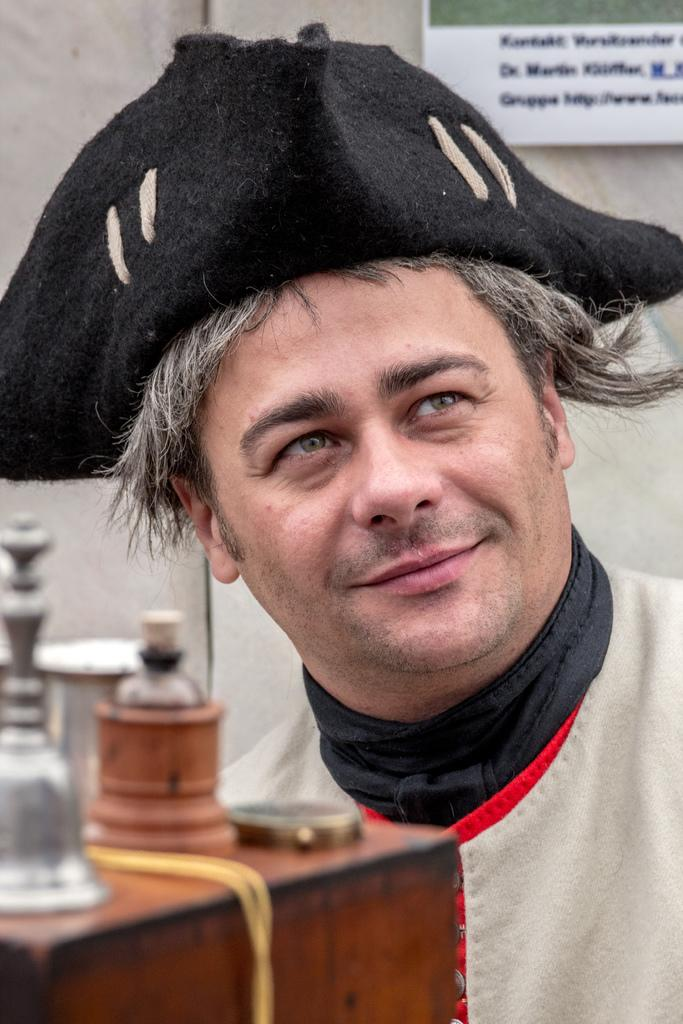What is the main subject of the image? There is a person in the image. Can you describe the person's attire? The person is wearing a cap on their head. What type of peace symbol can be seen on the canvas in the image? There is no peace symbol or canvas present in the image; it only features a person wearing a cap. 